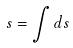Convert formula to latex. <formula><loc_0><loc_0><loc_500><loc_500>s = \int d s</formula> 